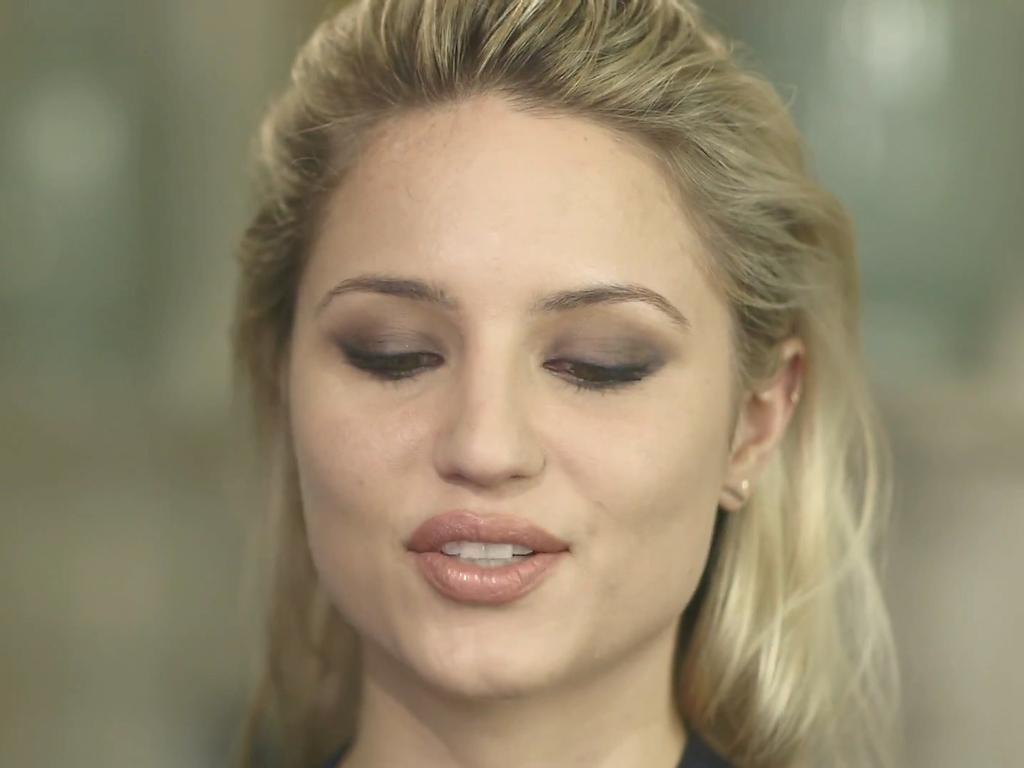How would you summarize this image in a sentence or two? In this picture we can see a woman and she is smiling and in the background we can see it is blurry. 